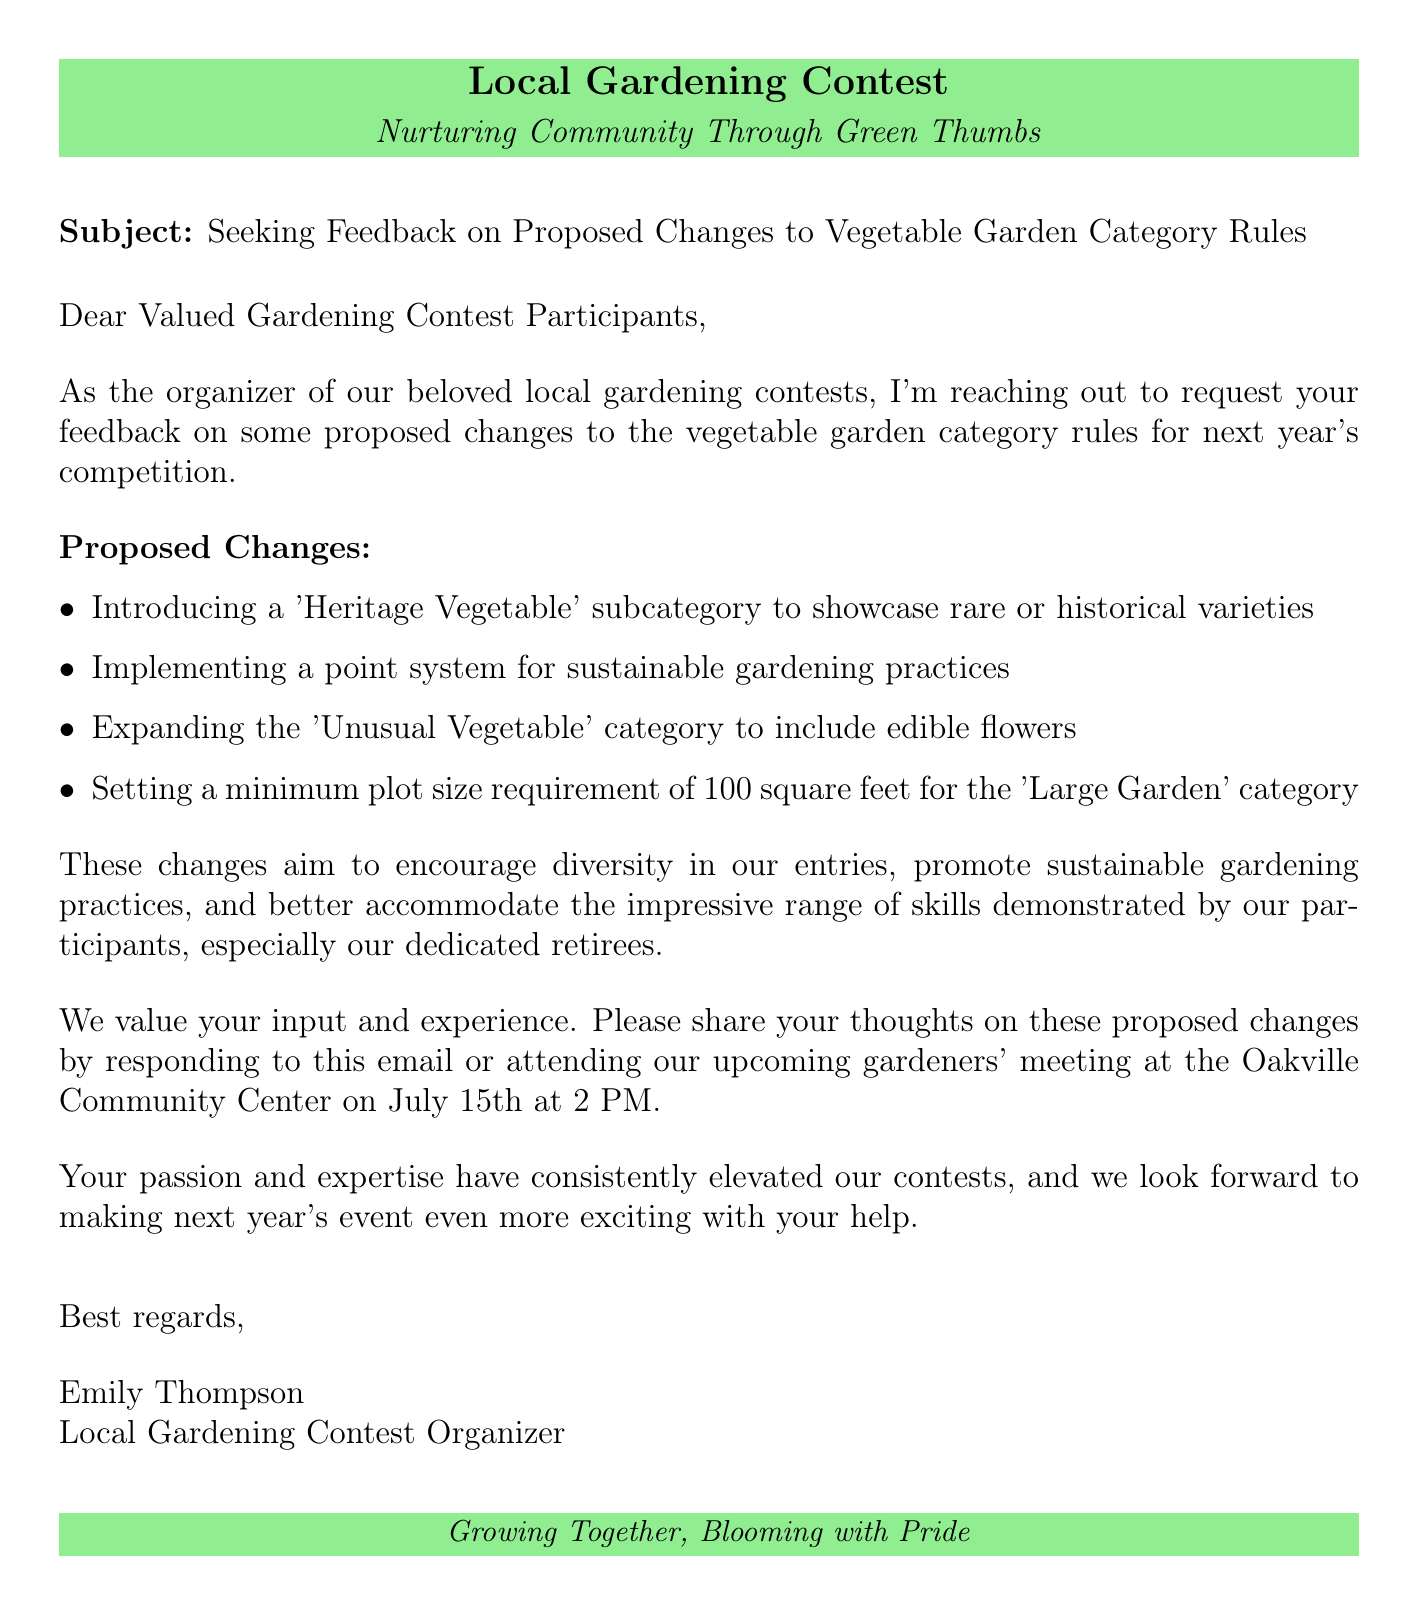What is the subject of the email? The subject line states the purpose of the email, which pertains to feedback on proposed changes.
Answer: Seeking Feedback on Proposed Changes to Vegetable Garden Category Rules Who is the sender of the email? The sender's name is provided at the end of the document, indicating who is organizing the contest.
Answer: Emily Thompson What is one of the proposed changes? The document lists specific changes proposed for the vegetable garden category.
Answer: Introducing a 'Heritage Vegetable' subcategory to showcase rare or historical varieties When is the upcoming gardeners' meeting? The date and time for the meeting where participants can give feedback is mentioned.
Answer: July 15th at 2 PM What is the rationale for the proposed changes? The rationale identifies the goals underlying the proposed changes outlined in the document.
Answer: These changes aim to encourage diversity in our entries, promote sustainable gardening practices, and better accommodate the impressive range of skills demonstrated by our participants, especially our dedicated retirees What is a new subcategory being introduced? The document specifies a new subcategory related to vegetable entries that will be introduced next year.
Answer: Heritage Vegetable What is the minimum plot size requirement for the 'Large Garden' category? One of the proposed changes includes a specific size requirement for a category in the contest.
Answer: 100 square feet What should participants do to provide feedback? The document outlines how participants can share their thoughts on the proposed changes.
Answer: Responding to this email or attending the upcoming gardeners' meeting What kind of topics are emphasized in the proposed changes? The email highlights specific themes that the proposed changes aim to address.
Answer: Diversity and sustainable gardening practices 